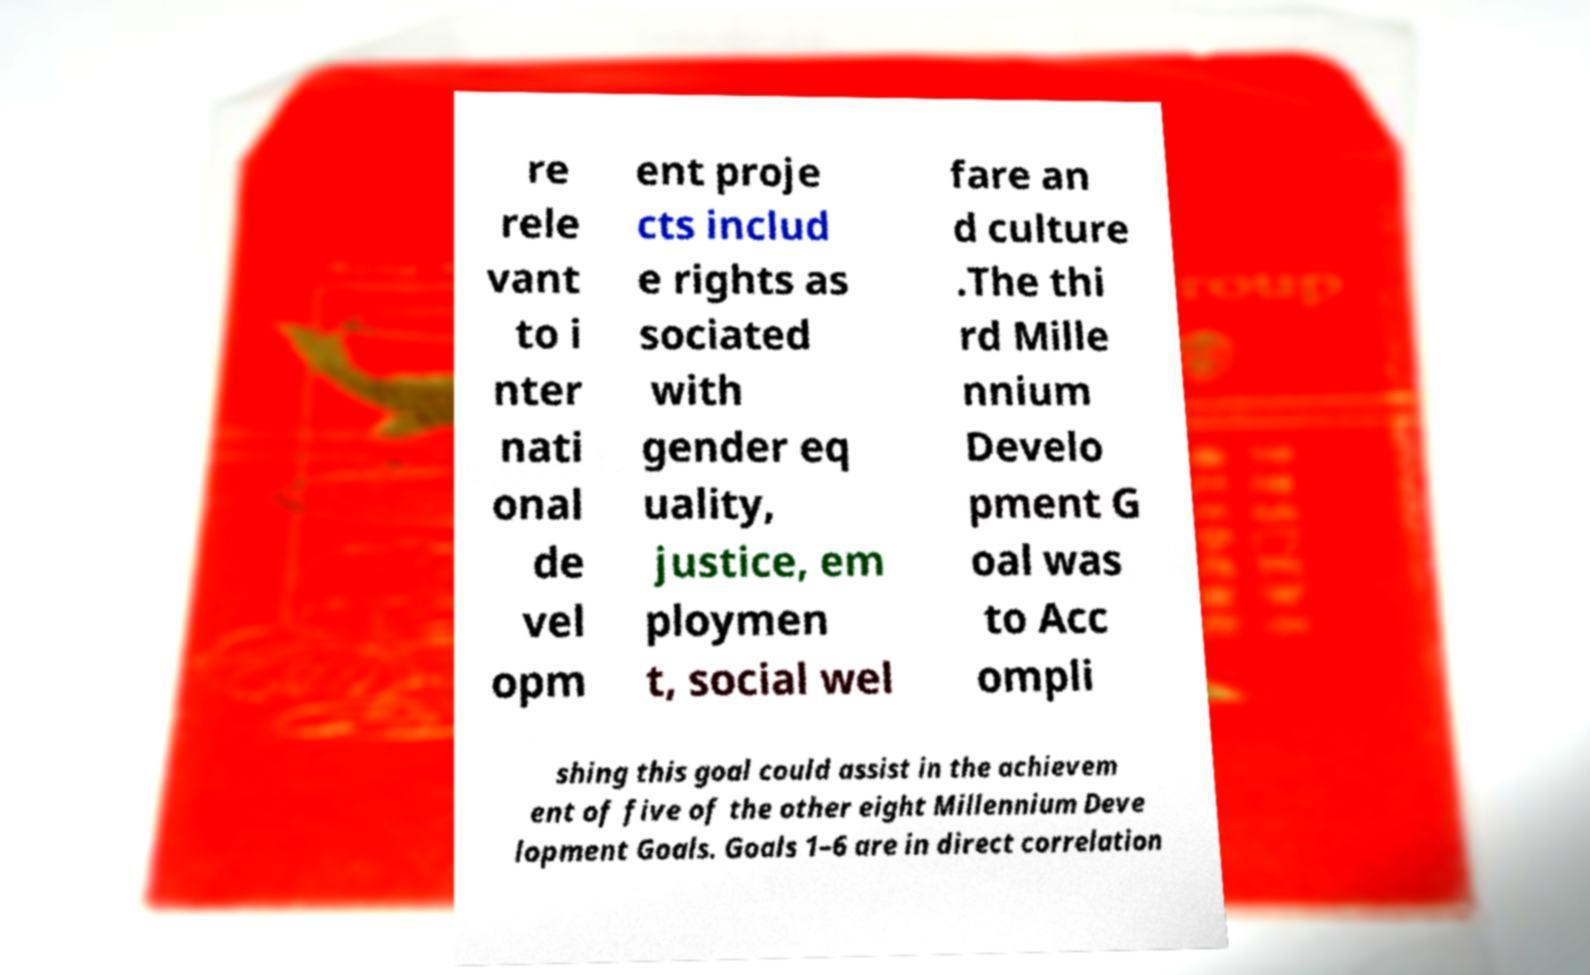Could you assist in decoding the text presented in this image and type it out clearly? re rele vant to i nter nati onal de vel opm ent proje cts includ e rights as sociated with gender eq uality, justice, em ploymen t, social wel fare an d culture .The thi rd Mille nnium Develo pment G oal was to Acc ompli shing this goal could assist in the achievem ent of five of the other eight Millennium Deve lopment Goals. Goals 1–6 are in direct correlation 